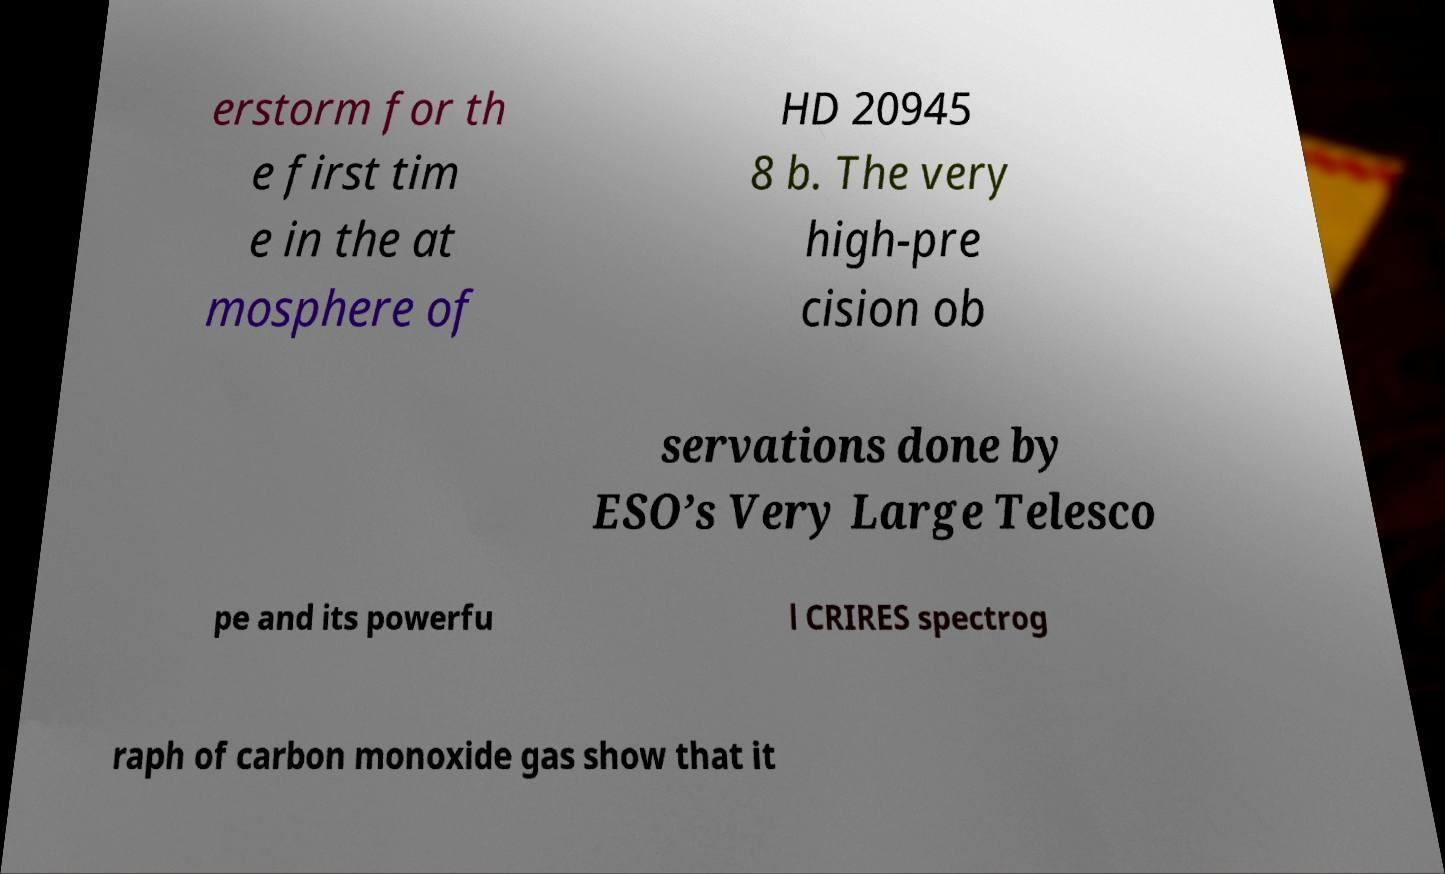Please read and relay the text visible in this image. What does it say? erstorm for th e first tim e in the at mosphere of HD 20945 8 b. The very high-pre cision ob servations done by ESO’s Very Large Telesco pe and its powerfu l CRIRES spectrog raph of carbon monoxide gas show that it 